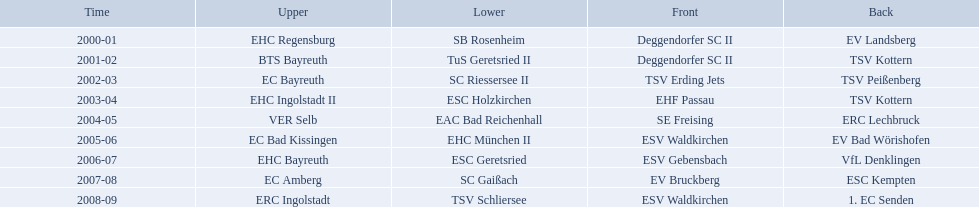Which teams played in the north? EHC Regensburg, BTS Bayreuth, EC Bayreuth, EHC Ingolstadt II, VER Selb, EC Bad Kissingen, EHC Bayreuth, EC Amberg, ERC Ingolstadt. Of these teams, which played during 2000-2001? EHC Regensburg. Which teams have won in the bavarian ice hockey leagues between 2000 and 2009? EHC Regensburg, SB Rosenheim, Deggendorfer SC II, EV Landsberg, BTS Bayreuth, TuS Geretsried II, TSV Kottern, EC Bayreuth, SC Riessersee II, TSV Erding Jets, TSV Peißenberg, EHC Ingolstadt II, ESC Holzkirchen, EHF Passau, TSV Kottern, VER Selb, EAC Bad Reichenhall, SE Freising, ERC Lechbruck, EC Bad Kissingen, EHC München II, ESV Waldkirchen, EV Bad Wörishofen, EHC Bayreuth, ESC Geretsried, ESV Gebensbach, VfL Denklingen, EC Amberg, SC Gaißach, EV Bruckberg, ESC Kempten, ERC Ingolstadt, TSV Schliersee, ESV Waldkirchen, 1. EC Senden. Which of these winning teams have won the north? EHC Regensburg, BTS Bayreuth, EC Bayreuth, EHC Ingolstadt II, VER Selb, EC Bad Kissingen, EHC Bayreuth, EC Amberg, ERC Ingolstadt. Which of the teams that won the north won in the 2000/2001 season? EHC Regensburg. 